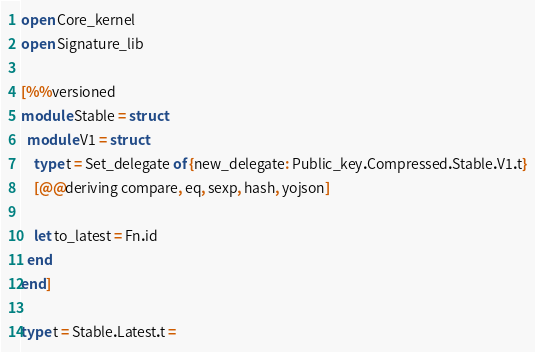Convert code to text. <code><loc_0><loc_0><loc_500><loc_500><_OCaml_>open Core_kernel
open Signature_lib

[%%versioned
module Stable = struct
  module V1 = struct
    type t = Set_delegate of {new_delegate: Public_key.Compressed.Stable.V1.t}
    [@@deriving compare, eq, sexp, hash, yojson]

    let to_latest = Fn.id
  end
end]

type t = Stable.Latest.t =</code> 